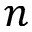Convert formula to latex. <formula><loc_0><loc_0><loc_500><loc_500>n</formula> 